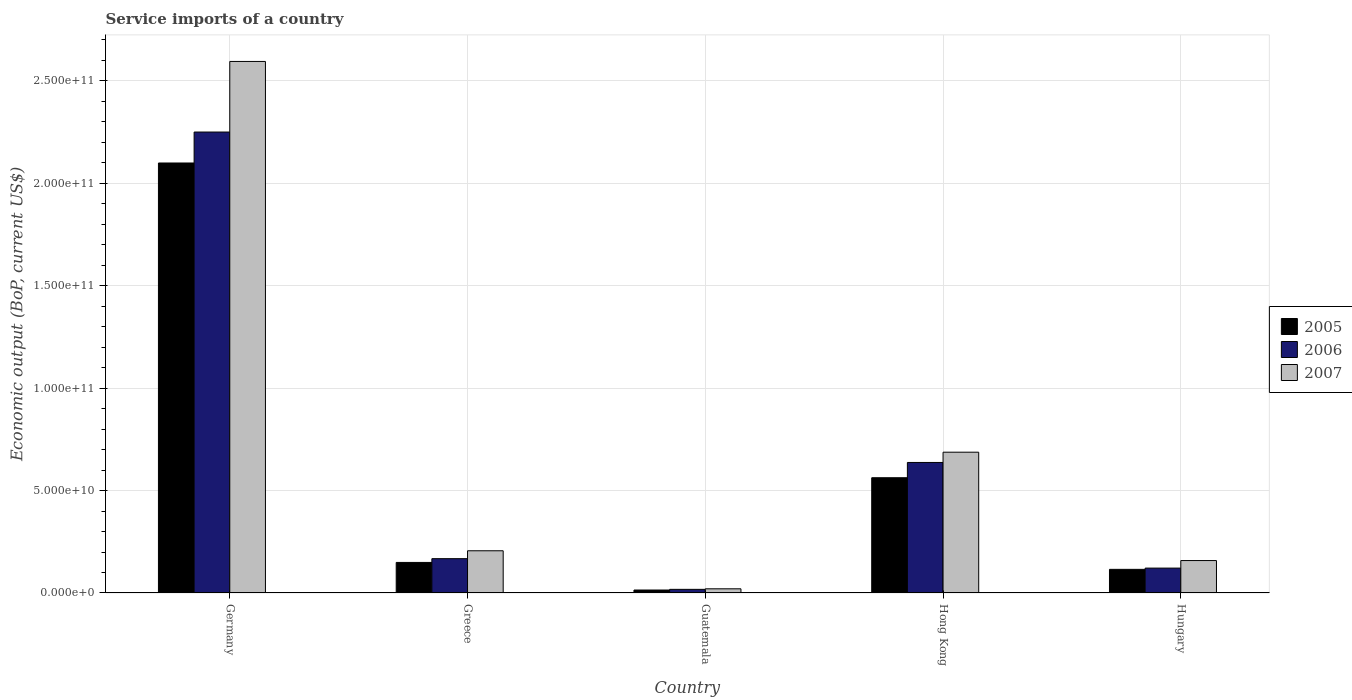How many groups of bars are there?
Your answer should be very brief. 5. Are the number of bars per tick equal to the number of legend labels?
Your answer should be compact. Yes. What is the label of the 2nd group of bars from the left?
Give a very brief answer. Greece. What is the service imports in 2005 in Greece?
Provide a short and direct response. 1.49e+1. Across all countries, what is the maximum service imports in 2007?
Provide a short and direct response. 2.59e+11. Across all countries, what is the minimum service imports in 2005?
Offer a terse response. 1.45e+09. In which country was the service imports in 2006 maximum?
Make the answer very short. Germany. In which country was the service imports in 2006 minimum?
Ensure brevity in your answer.  Guatemala. What is the total service imports in 2007 in the graph?
Offer a terse response. 3.67e+11. What is the difference between the service imports in 2007 in Germany and that in Hungary?
Your response must be concise. 2.44e+11. What is the difference between the service imports in 2007 in Guatemala and the service imports in 2005 in Germany?
Give a very brief answer. -2.08e+11. What is the average service imports in 2007 per country?
Your answer should be compact. 7.33e+1. What is the difference between the service imports of/in 2007 and service imports of/in 2006 in Hungary?
Keep it short and to the point. 3.69e+09. What is the ratio of the service imports in 2007 in Germany to that in Hungary?
Provide a short and direct response. 16.39. Is the difference between the service imports in 2007 in Germany and Hong Kong greater than the difference between the service imports in 2006 in Germany and Hong Kong?
Your answer should be very brief. Yes. What is the difference between the highest and the second highest service imports in 2006?
Your answer should be very brief. 1.61e+11. What is the difference between the highest and the lowest service imports in 2007?
Keep it short and to the point. 2.57e+11. Is the sum of the service imports in 2005 in Greece and Hungary greater than the maximum service imports in 2006 across all countries?
Provide a short and direct response. No. What does the 2nd bar from the left in Hong Kong represents?
Keep it short and to the point. 2006. What does the 2nd bar from the right in Hungary represents?
Make the answer very short. 2006. Are all the bars in the graph horizontal?
Ensure brevity in your answer.  No. How many countries are there in the graph?
Offer a very short reply. 5. What is the difference between two consecutive major ticks on the Y-axis?
Offer a terse response. 5.00e+1. Does the graph contain any zero values?
Provide a succinct answer. No. Where does the legend appear in the graph?
Keep it short and to the point. Center right. How are the legend labels stacked?
Your response must be concise. Vertical. What is the title of the graph?
Give a very brief answer. Service imports of a country. What is the label or title of the X-axis?
Offer a terse response. Country. What is the label or title of the Y-axis?
Your answer should be compact. Economic output (BoP, current US$). What is the Economic output (BoP, current US$) of 2005 in Germany?
Your answer should be very brief. 2.10e+11. What is the Economic output (BoP, current US$) in 2006 in Germany?
Your answer should be very brief. 2.25e+11. What is the Economic output (BoP, current US$) of 2007 in Germany?
Offer a terse response. 2.59e+11. What is the Economic output (BoP, current US$) in 2005 in Greece?
Provide a short and direct response. 1.49e+1. What is the Economic output (BoP, current US$) of 2006 in Greece?
Make the answer very short. 1.68e+1. What is the Economic output (BoP, current US$) of 2007 in Greece?
Make the answer very short. 2.06e+1. What is the Economic output (BoP, current US$) in 2005 in Guatemala?
Your answer should be compact. 1.45e+09. What is the Economic output (BoP, current US$) in 2006 in Guatemala?
Provide a short and direct response. 1.78e+09. What is the Economic output (BoP, current US$) in 2007 in Guatemala?
Give a very brief answer. 2.04e+09. What is the Economic output (BoP, current US$) of 2005 in Hong Kong?
Give a very brief answer. 5.63e+1. What is the Economic output (BoP, current US$) in 2006 in Hong Kong?
Your answer should be compact. 6.37e+1. What is the Economic output (BoP, current US$) in 2007 in Hong Kong?
Offer a very short reply. 6.87e+1. What is the Economic output (BoP, current US$) in 2005 in Hungary?
Make the answer very short. 1.15e+1. What is the Economic output (BoP, current US$) in 2006 in Hungary?
Keep it short and to the point. 1.21e+1. What is the Economic output (BoP, current US$) in 2007 in Hungary?
Ensure brevity in your answer.  1.58e+1. Across all countries, what is the maximum Economic output (BoP, current US$) of 2005?
Keep it short and to the point. 2.10e+11. Across all countries, what is the maximum Economic output (BoP, current US$) in 2006?
Make the answer very short. 2.25e+11. Across all countries, what is the maximum Economic output (BoP, current US$) of 2007?
Make the answer very short. 2.59e+11. Across all countries, what is the minimum Economic output (BoP, current US$) in 2005?
Your answer should be compact. 1.45e+09. Across all countries, what is the minimum Economic output (BoP, current US$) in 2006?
Provide a succinct answer. 1.78e+09. Across all countries, what is the minimum Economic output (BoP, current US$) of 2007?
Give a very brief answer. 2.04e+09. What is the total Economic output (BoP, current US$) in 2005 in the graph?
Ensure brevity in your answer.  2.94e+11. What is the total Economic output (BoP, current US$) in 2006 in the graph?
Your answer should be compact. 3.19e+11. What is the total Economic output (BoP, current US$) of 2007 in the graph?
Your answer should be compact. 3.67e+11. What is the difference between the Economic output (BoP, current US$) of 2005 in Germany and that in Greece?
Your answer should be compact. 1.95e+11. What is the difference between the Economic output (BoP, current US$) of 2006 in Germany and that in Greece?
Your answer should be very brief. 2.08e+11. What is the difference between the Economic output (BoP, current US$) in 2007 in Germany and that in Greece?
Your response must be concise. 2.39e+11. What is the difference between the Economic output (BoP, current US$) of 2005 in Germany and that in Guatemala?
Your answer should be very brief. 2.08e+11. What is the difference between the Economic output (BoP, current US$) of 2006 in Germany and that in Guatemala?
Your response must be concise. 2.23e+11. What is the difference between the Economic output (BoP, current US$) in 2007 in Germany and that in Guatemala?
Your answer should be compact. 2.57e+11. What is the difference between the Economic output (BoP, current US$) in 2005 in Germany and that in Hong Kong?
Your answer should be very brief. 1.54e+11. What is the difference between the Economic output (BoP, current US$) in 2006 in Germany and that in Hong Kong?
Your response must be concise. 1.61e+11. What is the difference between the Economic output (BoP, current US$) in 2007 in Germany and that in Hong Kong?
Your answer should be compact. 1.91e+11. What is the difference between the Economic output (BoP, current US$) of 2005 in Germany and that in Hungary?
Offer a very short reply. 1.98e+11. What is the difference between the Economic output (BoP, current US$) of 2006 in Germany and that in Hungary?
Offer a very short reply. 2.13e+11. What is the difference between the Economic output (BoP, current US$) of 2007 in Germany and that in Hungary?
Provide a succinct answer. 2.44e+11. What is the difference between the Economic output (BoP, current US$) of 2005 in Greece and that in Guatemala?
Ensure brevity in your answer.  1.35e+1. What is the difference between the Economic output (BoP, current US$) of 2006 in Greece and that in Guatemala?
Your answer should be very brief. 1.50e+1. What is the difference between the Economic output (BoP, current US$) in 2007 in Greece and that in Guatemala?
Your response must be concise. 1.86e+1. What is the difference between the Economic output (BoP, current US$) in 2005 in Greece and that in Hong Kong?
Keep it short and to the point. -4.13e+1. What is the difference between the Economic output (BoP, current US$) of 2006 in Greece and that in Hong Kong?
Your answer should be compact. -4.69e+1. What is the difference between the Economic output (BoP, current US$) in 2007 in Greece and that in Hong Kong?
Offer a very short reply. -4.81e+1. What is the difference between the Economic output (BoP, current US$) of 2005 in Greece and that in Hungary?
Your response must be concise. 3.38e+09. What is the difference between the Economic output (BoP, current US$) of 2006 in Greece and that in Hungary?
Keep it short and to the point. 4.61e+09. What is the difference between the Economic output (BoP, current US$) in 2007 in Greece and that in Hungary?
Ensure brevity in your answer.  4.77e+09. What is the difference between the Economic output (BoP, current US$) of 2005 in Guatemala and that in Hong Kong?
Your answer should be very brief. -5.48e+1. What is the difference between the Economic output (BoP, current US$) in 2006 in Guatemala and that in Hong Kong?
Ensure brevity in your answer.  -6.19e+1. What is the difference between the Economic output (BoP, current US$) of 2007 in Guatemala and that in Hong Kong?
Make the answer very short. -6.67e+1. What is the difference between the Economic output (BoP, current US$) in 2005 in Guatemala and that in Hungary?
Offer a very short reply. -1.01e+1. What is the difference between the Economic output (BoP, current US$) of 2006 in Guatemala and that in Hungary?
Provide a short and direct response. -1.04e+1. What is the difference between the Economic output (BoP, current US$) in 2007 in Guatemala and that in Hungary?
Keep it short and to the point. -1.38e+1. What is the difference between the Economic output (BoP, current US$) of 2005 in Hong Kong and that in Hungary?
Keep it short and to the point. 4.47e+1. What is the difference between the Economic output (BoP, current US$) in 2006 in Hong Kong and that in Hungary?
Provide a short and direct response. 5.16e+1. What is the difference between the Economic output (BoP, current US$) of 2007 in Hong Kong and that in Hungary?
Provide a succinct answer. 5.29e+1. What is the difference between the Economic output (BoP, current US$) of 2005 in Germany and the Economic output (BoP, current US$) of 2006 in Greece?
Keep it short and to the point. 1.93e+11. What is the difference between the Economic output (BoP, current US$) in 2005 in Germany and the Economic output (BoP, current US$) in 2007 in Greece?
Provide a short and direct response. 1.89e+11. What is the difference between the Economic output (BoP, current US$) of 2006 in Germany and the Economic output (BoP, current US$) of 2007 in Greece?
Your response must be concise. 2.04e+11. What is the difference between the Economic output (BoP, current US$) of 2005 in Germany and the Economic output (BoP, current US$) of 2006 in Guatemala?
Keep it short and to the point. 2.08e+11. What is the difference between the Economic output (BoP, current US$) in 2005 in Germany and the Economic output (BoP, current US$) in 2007 in Guatemala?
Offer a terse response. 2.08e+11. What is the difference between the Economic output (BoP, current US$) of 2006 in Germany and the Economic output (BoP, current US$) of 2007 in Guatemala?
Provide a short and direct response. 2.23e+11. What is the difference between the Economic output (BoP, current US$) in 2005 in Germany and the Economic output (BoP, current US$) in 2006 in Hong Kong?
Give a very brief answer. 1.46e+11. What is the difference between the Economic output (BoP, current US$) in 2005 in Germany and the Economic output (BoP, current US$) in 2007 in Hong Kong?
Provide a succinct answer. 1.41e+11. What is the difference between the Economic output (BoP, current US$) in 2006 in Germany and the Economic output (BoP, current US$) in 2007 in Hong Kong?
Offer a terse response. 1.56e+11. What is the difference between the Economic output (BoP, current US$) of 2005 in Germany and the Economic output (BoP, current US$) of 2006 in Hungary?
Provide a succinct answer. 1.98e+11. What is the difference between the Economic output (BoP, current US$) of 2005 in Germany and the Economic output (BoP, current US$) of 2007 in Hungary?
Offer a very short reply. 1.94e+11. What is the difference between the Economic output (BoP, current US$) in 2006 in Germany and the Economic output (BoP, current US$) in 2007 in Hungary?
Your answer should be compact. 2.09e+11. What is the difference between the Economic output (BoP, current US$) of 2005 in Greece and the Economic output (BoP, current US$) of 2006 in Guatemala?
Offer a very short reply. 1.31e+1. What is the difference between the Economic output (BoP, current US$) of 2005 in Greece and the Economic output (BoP, current US$) of 2007 in Guatemala?
Your answer should be very brief. 1.29e+1. What is the difference between the Economic output (BoP, current US$) of 2006 in Greece and the Economic output (BoP, current US$) of 2007 in Guatemala?
Provide a short and direct response. 1.47e+1. What is the difference between the Economic output (BoP, current US$) of 2005 in Greece and the Economic output (BoP, current US$) of 2006 in Hong Kong?
Provide a short and direct response. -4.88e+1. What is the difference between the Economic output (BoP, current US$) in 2005 in Greece and the Economic output (BoP, current US$) in 2007 in Hong Kong?
Your answer should be very brief. -5.38e+1. What is the difference between the Economic output (BoP, current US$) in 2006 in Greece and the Economic output (BoP, current US$) in 2007 in Hong Kong?
Ensure brevity in your answer.  -5.20e+1. What is the difference between the Economic output (BoP, current US$) in 2005 in Greece and the Economic output (BoP, current US$) in 2006 in Hungary?
Make the answer very short. 2.77e+09. What is the difference between the Economic output (BoP, current US$) in 2005 in Greece and the Economic output (BoP, current US$) in 2007 in Hungary?
Offer a very short reply. -9.18e+08. What is the difference between the Economic output (BoP, current US$) in 2006 in Greece and the Economic output (BoP, current US$) in 2007 in Hungary?
Offer a terse response. 9.25e+08. What is the difference between the Economic output (BoP, current US$) in 2005 in Guatemala and the Economic output (BoP, current US$) in 2006 in Hong Kong?
Provide a short and direct response. -6.23e+1. What is the difference between the Economic output (BoP, current US$) of 2005 in Guatemala and the Economic output (BoP, current US$) of 2007 in Hong Kong?
Make the answer very short. -6.73e+1. What is the difference between the Economic output (BoP, current US$) of 2006 in Guatemala and the Economic output (BoP, current US$) of 2007 in Hong Kong?
Keep it short and to the point. -6.69e+1. What is the difference between the Economic output (BoP, current US$) in 2005 in Guatemala and the Economic output (BoP, current US$) in 2006 in Hungary?
Your response must be concise. -1.07e+1. What is the difference between the Economic output (BoP, current US$) of 2005 in Guatemala and the Economic output (BoP, current US$) of 2007 in Hungary?
Your response must be concise. -1.44e+1. What is the difference between the Economic output (BoP, current US$) in 2006 in Guatemala and the Economic output (BoP, current US$) in 2007 in Hungary?
Offer a very short reply. -1.41e+1. What is the difference between the Economic output (BoP, current US$) in 2005 in Hong Kong and the Economic output (BoP, current US$) in 2006 in Hungary?
Your answer should be compact. 4.41e+1. What is the difference between the Economic output (BoP, current US$) in 2005 in Hong Kong and the Economic output (BoP, current US$) in 2007 in Hungary?
Your response must be concise. 4.04e+1. What is the difference between the Economic output (BoP, current US$) of 2006 in Hong Kong and the Economic output (BoP, current US$) of 2007 in Hungary?
Provide a short and direct response. 4.79e+1. What is the average Economic output (BoP, current US$) of 2005 per country?
Keep it short and to the point. 5.88e+1. What is the average Economic output (BoP, current US$) in 2006 per country?
Your answer should be compact. 6.39e+1. What is the average Economic output (BoP, current US$) of 2007 per country?
Provide a succinct answer. 7.33e+1. What is the difference between the Economic output (BoP, current US$) of 2005 and Economic output (BoP, current US$) of 2006 in Germany?
Offer a terse response. -1.51e+1. What is the difference between the Economic output (BoP, current US$) of 2005 and Economic output (BoP, current US$) of 2007 in Germany?
Ensure brevity in your answer.  -4.96e+1. What is the difference between the Economic output (BoP, current US$) of 2006 and Economic output (BoP, current US$) of 2007 in Germany?
Your answer should be very brief. -3.45e+1. What is the difference between the Economic output (BoP, current US$) in 2005 and Economic output (BoP, current US$) in 2006 in Greece?
Your answer should be very brief. -1.84e+09. What is the difference between the Economic output (BoP, current US$) of 2005 and Economic output (BoP, current US$) of 2007 in Greece?
Provide a succinct answer. -5.69e+09. What is the difference between the Economic output (BoP, current US$) in 2006 and Economic output (BoP, current US$) in 2007 in Greece?
Keep it short and to the point. -3.85e+09. What is the difference between the Economic output (BoP, current US$) of 2005 and Economic output (BoP, current US$) of 2006 in Guatemala?
Keep it short and to the point. -3.29e+08. What is the difference between the Economic output (BoP, current US$) of 2005 and Economic output (BoP, current US$) of 2007 in Guatemala?
Keep it short and to the point. -5.92e+08. What is the difference between the Economic output (BoP, current US$) of 2006 and Economic output (BoP, current US$) of 2007 in Guatemala?
Provide a succinct answer. -2.63e+08. What is the difference between the Economic output (BoP, current US$) in 2005 and Economic output (BoP, current US$) in 2006 in Hong Kong?
Provide a short and direct response. -7.45e+09. What is the difference between the Economic output (BoP, current US$) in 2005 and Economic output (BoP, current US$) in 2007 in Hong Kong?
Ensure brevity in your answer.  -1.25e+1. What is the difference between the Economic output (BoP, current US$) of 2006 and Economic output (BoP, current US$) of 2007 in Hong Kong?
Offer a terse response. -5.01e+09. What is the difference between the Economic output (BoP, current US$) in 2005 and Economic output (BoP, current US$) in 2006 in Hungary?
Provide a succinct answer. -6.10e+08. What is the difference between the Economic output (BoP, current US$) in 2005 and Economic output (BoP, current US$) in 2007 in Hungary?
Offer a terse response. -4.30e+09. What is the difference between the Economic output (BoP, current US$) of 2006 and Economic output (BoP, current US$) of 2007 in Hungary?
Provide a succinct answer. -3.69e+09. What is the ratio of the Economic output (BoP, current US$) in 2005 in Germany to that in Greece?
Offer a terse response. 14.07. What is the ratio of the Economic output (BoP, current US$) of 2006 in Germany to that in Greece?
Offer a very short reply. 13.43. What is the ratio of the Economic output (BoP, current US$) of 2007 in Germany to that in Greece?
Your response must be concise. 12.59. What is the ratio of the Economic output (BoP, current US$) of 2005 in Germany to that in Guatemala?
Ensure brevity in your answer.  144.78. What is the ratio of the Economic output (BoP, current US$) of 2006 in Germany to that in Guatemala?
Keep it short and to the point. 126.5. What is the ratio of the Economic output (BoP, current US$) in 2007 in Germany to that in Guatemala?
Your answer should be very brief. 127.1. What is the ratio of the Economic output (BoP, current US$) in 2005 in Germany to that in Hong Kong?
Offer a terse response. 3.73. What is the ratio of the Economic output (BoP, current US$) in 2006 in Germany to that in Hong Kong?
Your answer should be compact. 3.53. What is the ratio of the Economic output (BoP, current US$) of 2007 in Germany to that in Hong Kong?
Offer a very short reply. 3.78. What is the ratio of the Economic output (BoP, current US$) in 2005 in Germany to that in Hungary?
Offer a very short reply. 18.19. What is the ratio of the Economic output (BoP, current US$) of 2006 in Germany to that in Hungary?
Your answer should be very brief. 18.52. What is the ratio of the Economic output (BoP, current US$) in 2007 in Germany to that in Hungary?
Your answer should be very brief. 16.39. What is the ratio of the Economic output (BoP, current US$) in 2005 in Greece to that in Guatemala?
Offer a very short reply. 10.29. What is the ratio of the Economic output (BoP, current US$) of 2006 in Greece to that in Guatemala?
Give a very brief answer. 9.42. What is the ratio of the Economic output (BoP, current US$) in 2007 in Greece to that in Guatemala?
Offer a very short reply. 10.09. What is the ratio of the Economic output (BoP, current US$) in 2005 in Greece to that in Hong Kong?
Your answer should be compact. 0.27. What is the ratio of the Economic output (BoP, current US$) in 2006 in Greece to that in Hong Kong?
Ensure brevity in your answer.  0.26. What is the ratio of the Economic output (BoP, current US$) of 2007 in Greece to that in Hong Kong?
Offer a terse response. 0.3. What is the ratio of the Economic output (BoP, current US$) of 2005 in Greece to that in Hungary?
Keep it short and to the point. 1.29. What is the ratio of the Economic output (BoP, current US$) of 2006 in Greece to that in Hungary?
Provide a succinct answer. 1.38. What is the ratio of the Economic output (BoP, current US$) in 2007 in Greece to that in Hungary?
Your answer should be very brief. 1.3. What is the ratio of the Economic output (BoP, current US$) of 2005 in Guatemala to that in Hong Kong?
Give a very brief answer. 0.03. What is the ratio of the Economic output (BoP, current US$) of 2006 in Guatemala to that in Hong Kong?
Offer a very short reply. 0.03. What is the ratio of the Economic output (BoP, current US$) in 2007 in Guatemala to that in Hong Kong?
Ensure brevity in your answer.  0.03. What is the ratio of the Economic output (BoP, current US$) in 2005 in Guatemala to that in Hungary?
Provide a succinct answer. 0.13. What is the ratio of the Economic output (BoP, current US$) of 2006 in Guatemala to that in Hungary?
Your answer should be compact. 0.15. What is the ratio of the Economic output (BoP, current US$) in 2007 in Guatemala to that in Hungary?
Provide a short and direct response. 0.13. What is the ratio of the Economic output (BoP, current US$) of 2005 in Hong Kong to that in Hungary?
Provide a short and direct response. 4.88. What is the ratio of the Economic output (BoP, current US$) in 2006 in Hong Kong to that in Hungary?
Offer a very short reply. 5.25. What is the ratio of the Economic output (BoP, current US$) in 2007 in Hong Kong to that in Hungary?
Offer a very short reply. 4.34. What is the difference between the highest and the second highest Economic output (BoP, current US$) in 2005?
Give a very brief answer. 1.54e+11. What is the difference between the highest and the second highest Economic output (BoP, current US$) of 2006?
Provide a succinct answer. 1.61e+11. What is the difference between the highest and the second highest Economic output (BoP, current US$) in 2007?
Offer a terse response. 1.91e+11. What is the difference between the highest and the lowest Economic output (BoP, current US$) in 2005?
Offer a very short reply. 2.08e+11. What is the difference between the highest and the lowest Economic output (BoP, current US$) of 2006?
Ensure brevity in your answer.  2.23e+11. What is the difference between the highest and the lowest Economic output (BoP, current US$) of 2007?
Your answer should be compact. 2.57e+11. 